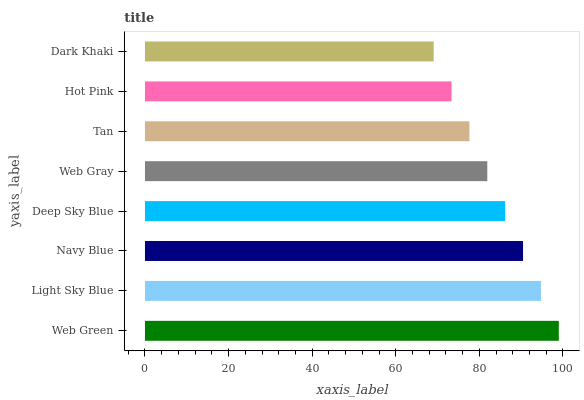Is Dark Khaki the minimum?
Answer yes or no. Yes. Is Web Green the maximum?
Answer yes or no. Yes. Is Light Sky Blue the minimum?
Answer yes or no. No. Is Light Sky Blue the maximum?
Answer yes or no. No. Is Web Green greater than Light Sky Blue?
Answer yes or no. Yes. Is Light Sky Blue less than Web Green?
Answer yes or no. Yes. Is Light Sky Blue greater than Web Green?
Answer yes or no. No. Is Web Green less than Light Sky Blue?
Answer yes or no. No. Is Deep Sky Blue the high median?
Answer yes or no. Yes. Is Web Gray the low median?
Answer yes or no. Yes. Is Light Sky Blue the high median?
Answer yes or no. No. Is Light Sky Blue the low median?
Answer yes or no. No. 